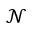Convert formula to latex. <formula><loc_0><loc_0><loc_500><loc_500>\mathcal { N }</formula> 